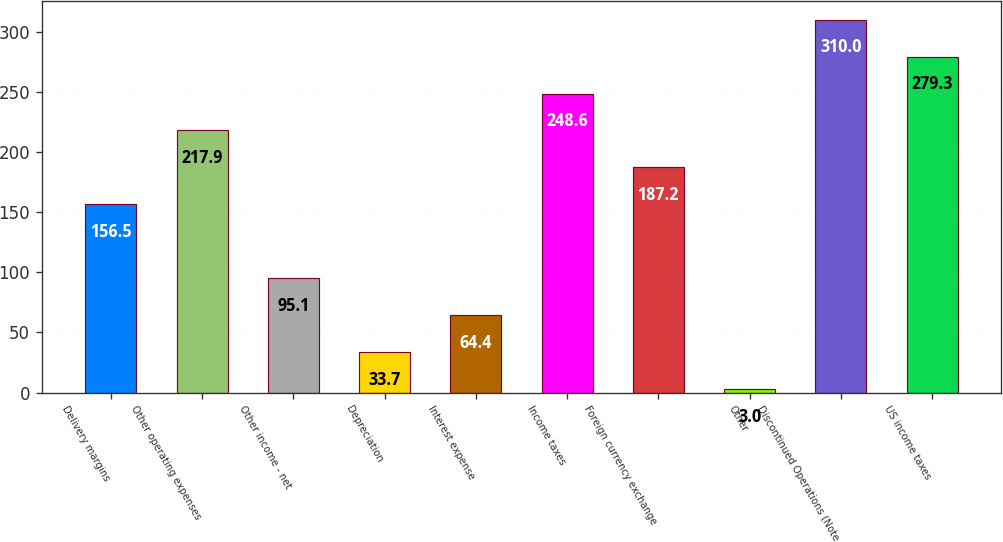<chart> <loc_0><loc_0><loc_500><loc_500><bar_chart><fcel>Delivery margins<fcel>Other operating expenses<fcel>Other income - net<fcel>Depreciation<fcel>Interest expense<fcel>Income taxes<fcel>Foreign currency exchange<fcel>Other<fcel>Discontinued Operations (Note<fcel>US income taxes<nl><fcel>156.5<fcel>217.9<fcel>95.1<fcel>33.7<fcel>64.4<fcel>248.6<fcel>187.2<fcel>3<fcel>310<fcel>279.3<nl></chart> 